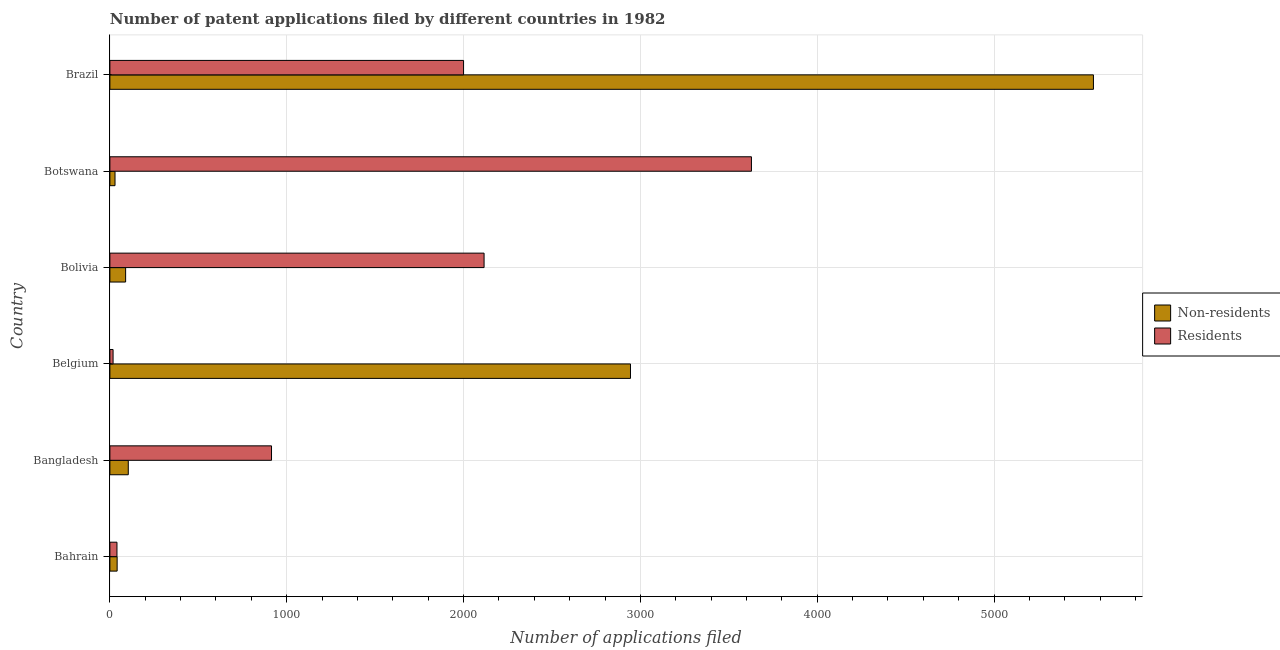How many groups of bars are there?
Ensure brevity in your answer.  6. Are the number of bars on each tick of the Y-axis equal?
Keep it short and to the point. Yes. How many bars are there on the 3rd tick from the top?
Offer a very short reply. 2. What is the number of patent applications by residents in Bolivia?
Offer a very short reply. 2116. Across all countries, what is the maximum number of patent applications by non residents?
Your answer should be very brief. 5562. Across all countries, what is the minimum number of patent applications by non residents?
Your answer should be compact. 29. In which country was the number of patent applications by non residents maximum?
Your answer should be very brief. Brazil. What is the total number of patent applications by residents in the graph?
Your answer should be compact. 8716. What is the difference between the number of patent applications by residents in Bangladesh and that in Brazil?
Your answer should be very brief. -1086. What is the difference between the number of patent applications by residents in Botswana and the number of patent applications by non residents in Belgium?
Give a very brief answer. 684. What is the average number of patent applications by residents per country?
Give a very brief answer. 1452.67. What is the difference between the number of patent applications by residents and number of patent applications by non residents in Bangladesh?
Provide a succinct answer. 810. In how many countries, is the number of patent applications by residents greater than 1600 ?
Keep it short and to the point. 3. What is the ratio of the number of patent applications by non residents in Belgium to that in Brazil?
Offer a terse response. 0.53. What is the difference between the highest and the second highest number of patent applications by non residents?
Keep it short and to the point. 2618. What is the difference between the highest and the lowest number of patent applications by residents?
Offer a terse response. 3610. What does the 1st bar from the top in Brazil represents?
Offer a very short reply. Residents. What does the 2nd bar from the bottom in Brazil represents?
Your response must be concise. Residents. How many bars are there?
Offer a very short reply. 12. Are all the bars in the graph horizontal?
Offer a terse response. Yes. How many countries are there in the graph?
Make the answer very short. 6. Does the graph contain any zero values?
Give a very brief answer. No. How many legend labels are there?
Ensure brevity in your answer.  2. How are the legend labels stacked?
Offer a terse response. Vertical. What is the title of the graph?
Ensure brevity in your answer.  Number of patent applications filed by different countries in 1982. What is the label or title of the X-axis?
Provide a short and direct response. Number of applications filed. What is the label or title of the Y-axis?
Your answer should be compact. Country. What is the Number of applications filed of Non-residents in Bahrain?
Make the answer very short. 41. What is the Number of applications filed in Residents in Bahrain?
Offer a terse response. 40. What is the Number of applications filed in Non-residents in Bangladesh?
Provide a short and direct response. 104. What is the Number of applications filed in Residents in Bangladesh?
Offer a very short reply. 914. What is the Number of applications filed of Non-residents in Belgium?
Offer a very short reply. 2944. What is the Number of applications filed of Residents in Belgium?
Offer a terse response. 18. What is the Number of applications filed in Non-residents in Bolivia?
Offer a very short reply. 89. What is the Number of applications filed in Residents in Bolivia?
Provide a succinct answer. 2116. What is the Number of applications filed in Non-residents in Botswana?
Give a very brief answer. 29. What is the Number of applications filed of Residents in Botswana?
Keep it short and to the point. 3628. What is the Number of applications filed of Non-residents in Brazil?
Provide a succinct answer. 5562. Across all countries, what is the maximum Number of applications filed in Non-residents?
Offer a very short reply. 5562. Across all countries, what is the maximum Number of applications filed of Residents?
Provide a short and direct response. 3628. Across all countries, what is the minimum Number of applications filed of Non-residents?
Your answer should be very brief. 29. Across all countries, what is the minimum Number of applications filed of Residents?
Your response must be concise. 18. What is the total Number of applications filed in Non-residents in the graph?
Offer a very short reply. 8769. What is the total Number of applications filed in Residents in the graph?
Your answer should be compact. 8716. What is the difference between the Number of applications filed in Non-residents in Bahrain and that in Bangladesh?
Offer a very short reply. -63. What is the difference between the Number of applications filed of Residents in Bahrain and that in Bangladesh?
Your answer should be compact. -874. What is the difference between the Number of applications filed in Non-residents in Bahrain and that in Belgium?
Keep it short and to the point. -2903. What is the difference between the Number of applications filed in Residents in Bahrain and that in Belgium?
Your answer should be very brief. 22. What is the difference between the Number of applications filed of Non-residents in Bahrain and that in Bolivia?
Offer a terse response. -48. What is the difference between the Number of applications filed in Residents in Bahrain and that in Bolivia?
Offer a very short reply. -2076. What is the difference between the Number of applications filed in Non-residents in Bahrain and that in Botswana?
Provide a short and direct response. 12. What is the difference between the Number of applications filed in Residents in Bahrain and that in Botswana?
Offer a very short reply. -3588. What is the difference between the Number of applications filed in Non-residents in Bahrain and that in Brazil?
Make the answer very short. -5521. What is the difference between the Number of applications filed in Residents in Bahrain and that in Brazil?
Make the answer very short. -1960. What is the difference between the Number of applications filed in Non-residents in Bangladesh and that in Belgium?
Make the answer very short. -2840. What is the difference between the Number of applications filed in Residents in Bangladesh and that in Belgium?
Provide a short and direct response. 896. What is the difference between the Number of applications filed of Non-residents in Bangladesh and that in Bolivia?
Offer a very short reply. 15. What is the difference between the Number of applications filed in Residents in Bangladesh and that in Bolivia?
Ensure brevity in your answer.  -1202. What is the difference between the Number of applications filed in Residents in Bangladesh and that in Botswana?
Provide a short and direct response. -2714. What is the difference between the Number of applications filed of Non-residents in Bangladesh and that in Brazil?
Your response must be concise. -5458. What is the difference between the Number of applications filed of Residents in Bangladesh and that in Brazil?
Ensure brevity in your answer.  -1086. What is the difference between the Number of applications filed in Non-residents in Belgium and that in Bolivia?
Your response must be concise. 2855. What is the difference between the Number of applications filed in Residents in Belgium and that in Bolivia?
Your response must be concise. -2098. What is the difference between the Number of applications filed in Non-residents in Belgium and that in Botswana?
Make the answer very short. 2915. What is the difference between the Number of applications filed in Residents in Belgium and that in Botswana?
Your answer should be very brief. -3610. What is the difference between the Number of applications filed in Non-residents in Belgium and that in Brazil?
Offer a terse response. -2618. What is the difference between the Number of applications filed in Residents in Belgium and that in Brazil?
Keep it short and to the point. -1982. What is the difference between the Number of applications filed of Non-residents in Bolivia and that in Botswana?
Your response must be concise. 60. What is the difference between the Number of applications filed of Residents in Bolivia and that in Botswana?
Ensure brevity in your answer.  -1512. What is the difference between the Number of applications filed in Non-residents in Bolivia and that in Brazil?
Ensure brevity in your answer.  -5473. What is the difference between the Number of applications filed in Residents in Bolivia and that in Brazil?
Make the answer very short. 116. What is the difference between the Number of applications filed in Non-residents in Botswana and that in Brazil?
Offer a very short reply. -5533. What is the difference between the Number of applications filed in Residents in Botswana and that in Brazil?
Offer a very short reply. 1628. What is the difference between the Number of applications filed of Non-residents in Bahrain and the Number of applications filed of Residents in Bangladesh?
Provide a short and direct response. -873. What is the difference between the Number of applications filed in Non-residents in Bahrain and the Number of applications filed in Residents in Bolivia?
Provide a short and direct response. -2075. What is the difference between the Number of applications filed of Non-residents in Bahrain and the Number of applications filed of Residents in Botswana?
Your answer should be compact. -3587. What is the difference between the Number of applications filed of Non-residents in Bahrain and the Number of applications filed of Residents in Brazil?
Keep it short and to the point. -1959. What is the difference between the Number of applications filed in Non-residents in Bangladesh and the Number of applications filed in Residents in Bolivia?
Keep it short and to the point. -2012. What is the difference between the Number of applications filed of Non-residents in Bangladesh and the Number of applications filed of Residents in Botswana?
Your answer should be very brief. -3524. What is the difference between the Number of applications filed in Non-residents in Bangladesh and the Number of applications filed in Residents in Brazil?
Provide a succinct answer. -1896. What is the difference between the Number of applications filed in Non-residents in Belgium and the Number of applications filed in Residents in Bolivia?
Provide a short and direct response. 828. What is the difference between the Number of applications filed of Non-residents in Belgium and the Number of applications filed of Residents in Botswana?
Your response must be concise. -684. What is the difference between the Number of applications filed of Non-residents in Belgium and the Number of applications filed of Residents in Brazil?
Provide a short and direct response. 944. What is the difference between the Number of applications filed of Non-residents in Bolivia and the Number of applications filed of Residents in Botswana?
Ensure brevity in your answer.  -3539. What is the difference between the Number of applications filed in Non-residents in Bolivia and the Number of applications filed in Residents in Brazil?
Offer a very short reply. -1911. What is the difference between the Number of applications filed in Non-residents in Botswana and the Number of applications filed in Residents in Brazil?
Make the answer very short. -1971. What is the average Number of applications filed of Non-residents per country?
Your answer should be compact. 1461.5. What is the average Number of applications filed in Residents per country?
Keep it short and to the point. 1452.67. What is the difference between the Number of applications filed of Non-residents and Number of applications filed of Residents in Bangladesh?
Make the answer very short. -810. What is the difference between the Number of applications filed in Non-residents and Number of applications filed in Residents in Belgium?
Ensure brevity in your answer.  2926. What is the difference between the Number of applications filed of Non-residents and Number of applications filed of Residents in Bolivia?
Ensure brevity in your answer.  -2027. What is the difference between the Number of applications filed in Non-residents and Number of applications filed in Residents in Botswana?
Make the answer very short. -3599. What is the difference between the Number of applications filed of Non-residents and Number of applications filed of Residents in Brazil?
Offer a very short reply. 3562. What is the ratio of the Number of applications filed in Non-residents in Bahrain to that in Bangladesh?
Your response must be concise. 0.39. What is the ratio of the Number of applications filed in Residents in Bahrain to that in Bangladesh?
Ensure brevity in your answer.  0.04. What is the ratio of the Number of applications filed in Non-residents in Bahrain to that in Belgium?
Give a very brief answer. 0.01. What is the ratio of the Number of applications filed of Residents in Bahrain to that in Belgium?
Your answer should be compact. 2.22. What is the ratio of the Number of applications filed in Non-residents in Bahrain to that in Bolivia?
Give a very brief answer. 0.46. What is the ratio of the Number of applications filed in Residents in Bahrain to that in Bolivia?
Provide a short and direct response. 0.02. What is the ratio of the Number of applications filed of Non-residents in Bahrain to that in Botswana?
Ensure brevity in your answer.  1.41. What is the ratio of the Number of applications filed in Residents in Bahrain to that in Botswana?
Provide a succinct answer. 0.01. What is the ratio of the Number of applications filed in Non-residents in Bahrain to that in Brazil?
Make the answer very short. 0.01. What is the ratio of the Number of applications filed of Non-residents in Bangladesh to that in Belgium?
Ensure brevity in your answer.  0.04. What is the ratio of the Number of applications filed in Residents in Bangladesh to that in Belgium?
Make the answer very short. 50.78. What is the ratio of the Number of applications filed of Non-residents in Bangladesh to that in Bolivia?
Your answer should be compact. 1.17. What is the ratio of the Number of applications filed in Residents in Bangladesh to that in Bolivia?
Keep it short and to the point. 0.43. What is the ratio of the Number of applications filed of Non-residents in Bangladesh to that in Botswana?
Keep it short and to the point. 3.59. What is the ratio of the Number of applications filed of Residents in Bangladesh to that in Botswana?
Ensure brevity in your answer.  0.25. What is the ratio of the Number of applications filed in Non-residents in Bangladesh to that in Brazil?
Make the answer very short. 0.02. What is the ratio of the Number of applications filed of Residents in Bangladesh to that in Brazil?
Give a very brief answer. 0.46. What is the ratio of the Number of applications filed of Non-residents in Belgium to that in Bolivia?
Ensure brevity in your answer.  33.08. What is the ratio of the Number of applications filed in Residents in Belgium to that in Bolivia?
Keep it short and to the point. 0.01. What is the ratio of the Number of applications filed in Non-residents in Belgium to that in Botswana?
Provide a succinct answer. 101.52. What is the ratio of the Number of applications filed of Residents in Belgium to that in Botswana?
Your response must be concise. 0.01. What is the ratio of the Number of applications filed in Non-residents in Belgium to that in Brazil?
Your response must be concise. 0.53. What is the ratio of the Number of applications filed of Residents in Belgium to that in Brazil?
Provide a short and direct response. 0.01. What is the ratio of the Number of applications filed of Non-residents in Bolivia to that in Botswana?
Your answer should be compact. 3.07. What is the ratio of the Number of applications filed of Residents in Bolivia to that in Botswana?
Your answer should be very brief. 0.58. What is the ratio of the Number of applications filed of Non-residents in Bolivia to that in Brazil?
Your answer should be compact. 0.02. What is the ratio of the Number of applications filed in Residents in Bolivia to that in Brazil?
Your answer should be compact. 1.06. What is the ratio of the Number of applications filed of Non-residents in Botswana to that in Brazil?
Ensure brevity in your answer.  0.01. What is the ratio of the Number of applications filed in Residents in Botswana to that in Brazil?
Keep it short and to the point. 1.81. What is the difference between the highest and the second highest Number of applications filed of Non-residents?
Offer a terse response. 2618. What is the difference between the highest and the second highest Number of applications filed of Residents?
Your answer should be compact. 1512. What is the difference between the highest and the lowest Number of applications filed of Non-residents?
Your answer should be very brief. 5533. What is the difference between the highest and the lowest Number of applications filed in Residents?
Offer a very short reply. 3610. 